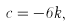Convert formula to latex. <formula><loc_0><loc_0><loc_500><loc_500>c = - 6 k ,</formula> 